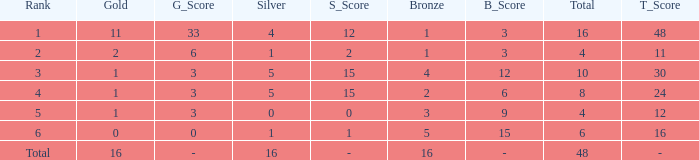What is the total gold that has bronze less than 2, a silver of 1 and total more than 4? None. 